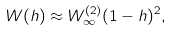Convert formula to latex. <formula><loc_0><loc_0><loc_500><loc_500>W ( h ) \approx W _ { \infty } ^ { ( 2 ) } ( 1 - h ) ^ { 2 } ,</formula> 